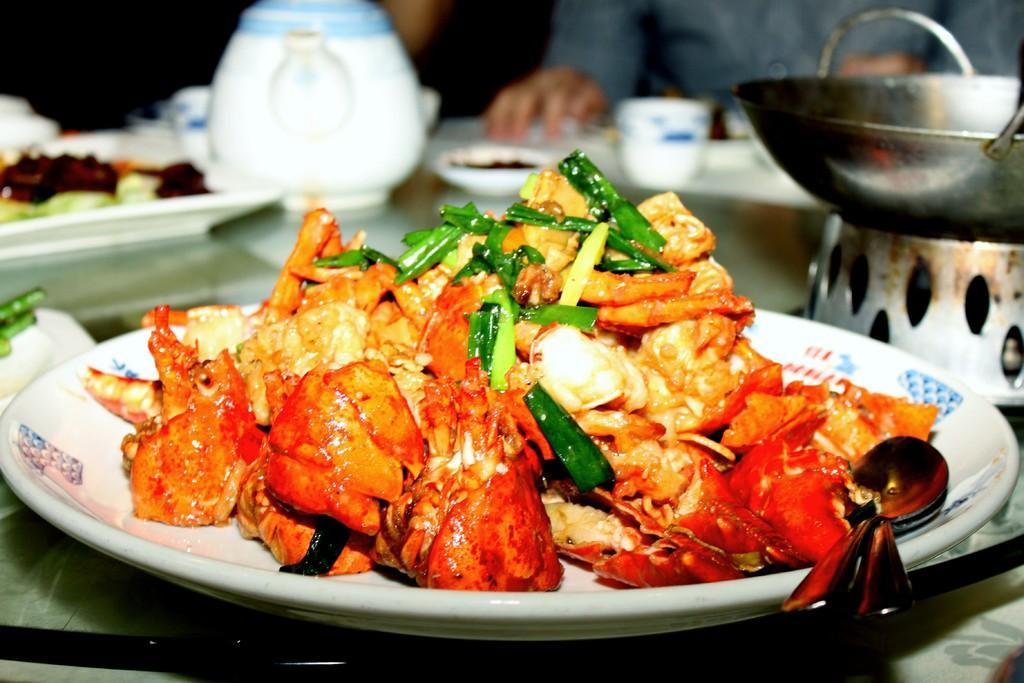Describe this image in one or two sentences. This is a plate, which contains food in it. I can see two spoons placed on the plate. This looks like a karahi, kettle, plates, cup are placed on the table. In the background, I can see a person. 